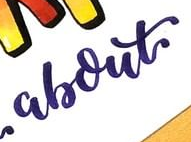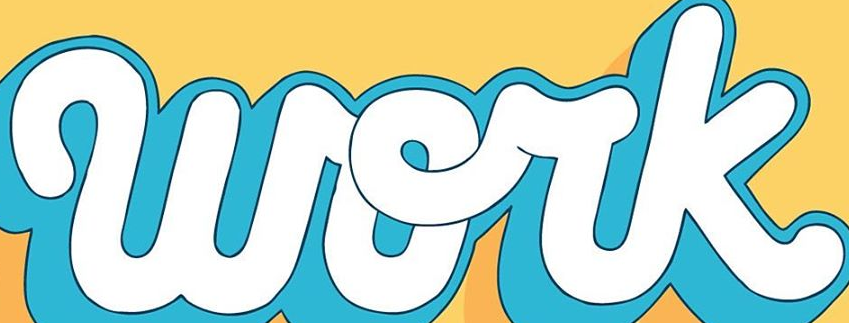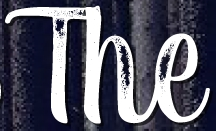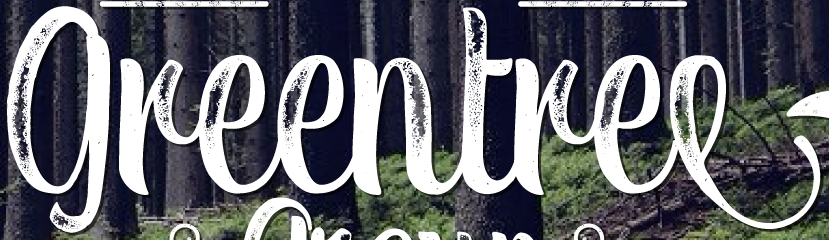What text is displayed in these images sequentially, separated by a semicolon? about; work; The; greentree 